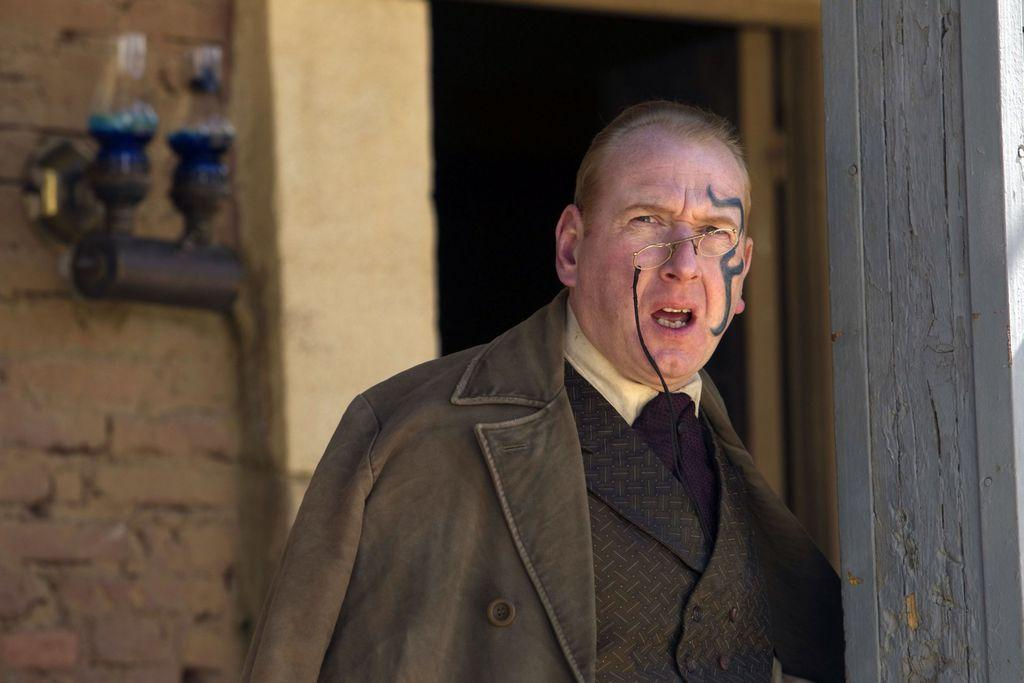What is the person in the image doing? The person is standing near a pillar in the image. What architectural feature can be seen in the image? There is a door in the image. What is the background of the image made of? There is a wall in the image. Is there anything attached to the wall in the image? Yes, there is an object attached to the wall in the image. What type of rock is the person holding in the image? There is no rock present in the image; the person is standing near a pillar. Can you describe the person's brain in the image? There is no information about the person's brain in the image, as it is not visible. 